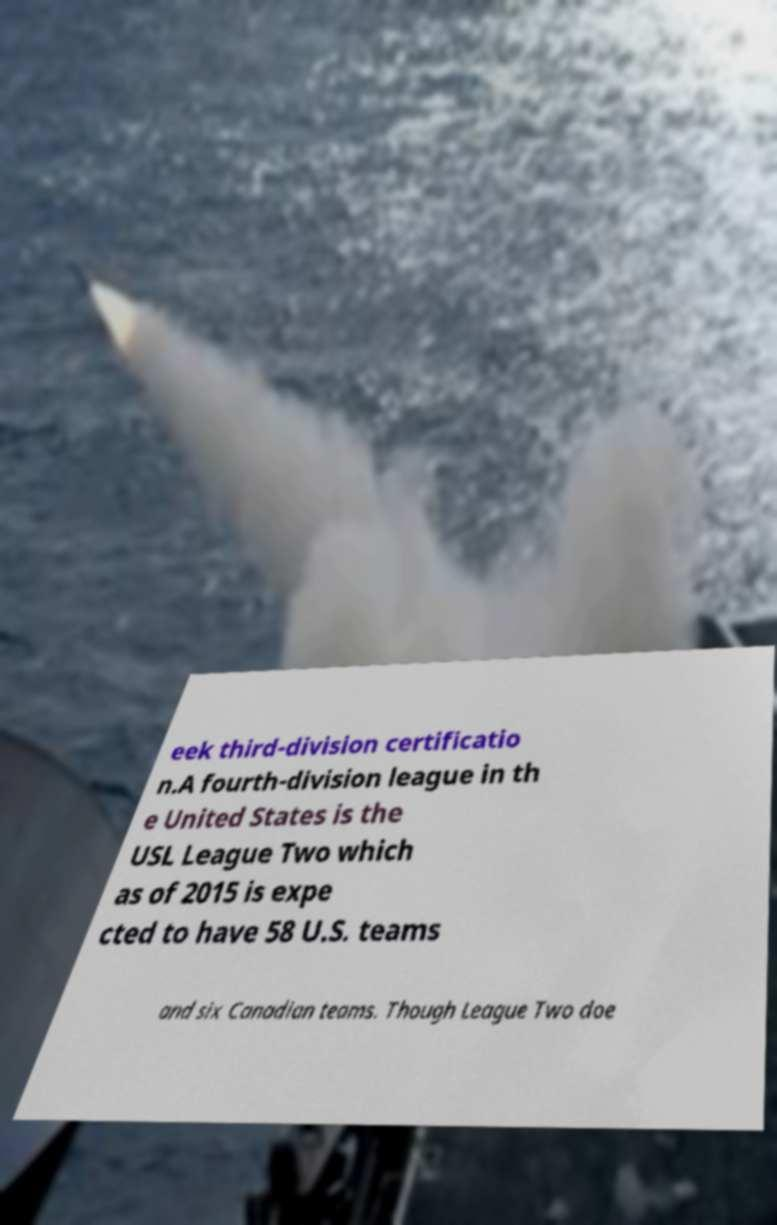There's text embedded in this image that I need extracted. Can you transcribe it verbatim? eek third-division certificatio n.A fourth-division league in th e United States is the USL League Two which as of 2015 is expe cted to have 58 U.S. teams and six Canadian teams. Though League Two doe 